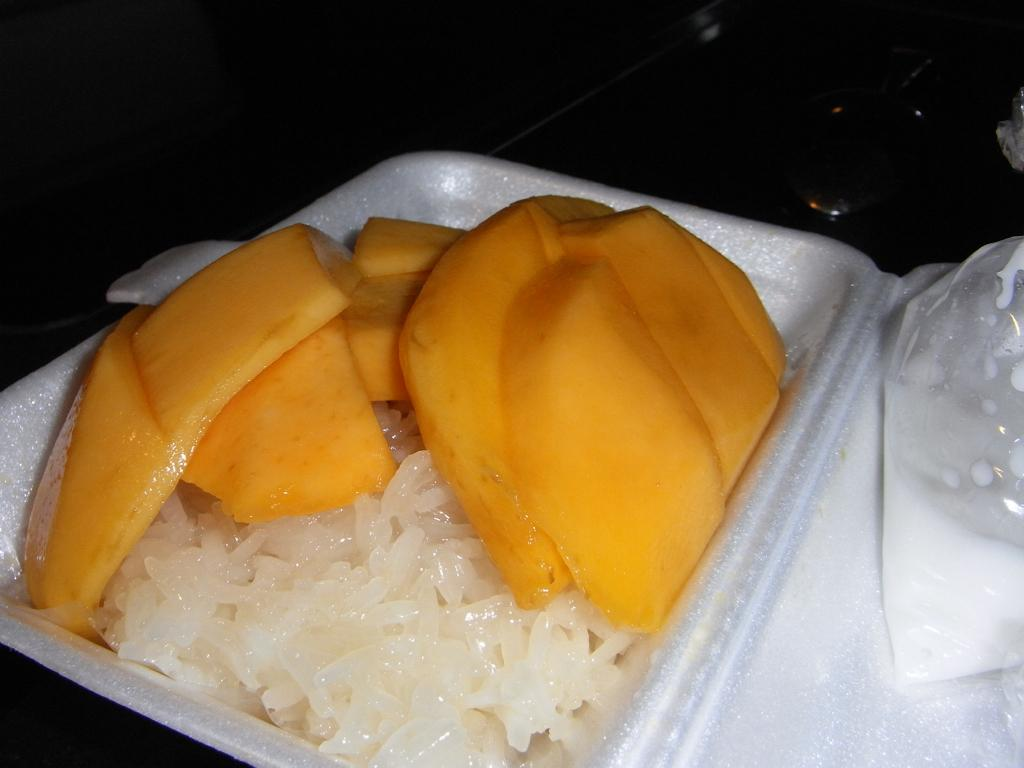What type of fruit is visible in the image? There are mango slices in the image. What type of food is also present in the image? There is rice in the image. What is the plate made of, and what color is it? The plate is made of white color thermocol. What is on top of the plate in the image? The plate has a cover with a food item. How would you describe the background of the image? The background of the image is dark. What type of reward is the deer receiving in the image? There is no deer present in the image, and therefore no reward can be observed. What type of pen is visible in the image? There is no pen present in the image. 